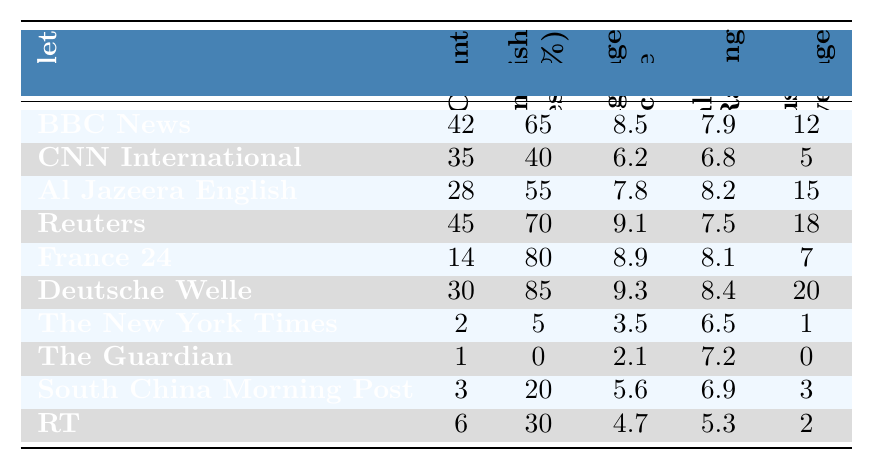What is the language count for BBC News? Referring directly to the table, the language count for BBC News is listed as 42.
Answer: 42 Which news outlet has the highest percentage of non-English articles? By looking at the percentages in the non-English articles column, Deutsche Welle has the highest percentage at 85%.
Answer: 85% How many indigenous languages does The Guardian cover? The table shows that The Guardian covers 0 indigenous languages.
Answer: 0 What is the cultural sensitivity rating for Al Jazeera English? The cultural sensitivity rating for Al Jazeera English is 8.2, as indicated in the corresponding column.
Answer: 8.2 Which news outlet has the lowest local language usage score? The local language usage score for The New York Times is 3.5, which is the lowest score when compared to other outlets.
Answer: 3.5 What is the average non-English articles percentage for all the news outlets? The sum of the non-English articles percentages is 65 + 40 + 55 + 70 + 80 + 85 + 5 + 0 + 20 + 30 = 450. There are 10 outlets, so the average is 450/10 = 45.
Answer: 45 Is the cultural sensitivity rating for CNN International higher than that of The New York Times? The cultural sensitivity rating for CNN International is 6.8, and for The New York Times, it is 6.5. Since 6.8 is greater than 6.5, the statement is true.
Answer: Yes What is the difference in language count between Reuters and The Guardian? Reuters has a language count of 45 and The Guardian has 1. The difference is 45 - 1 = 44.
Answer: 44 Which outlet has a higher local language usage score, France 24 or RT? France 24 has a local language usage score of 8.9 while RT has a score of 4.7. Since 8.9 is greater than 4.7, France 24 has the higher score.
Answer: France 24 What can we infer about the relationship between language count and cultural sensitivity ratings based on the table? Examining the table shows that news outlets with a higher language count (like Reuters and Deutsche Welle) often have relatively high cultural sensitivity ratings, while those with very low language counts (like The Guardian and The New York Times) have lower cultural sensitivity ratings. This suggests a possible positive correlation between language count and cultural sensitivity.
Answer: There is a potential correlation 